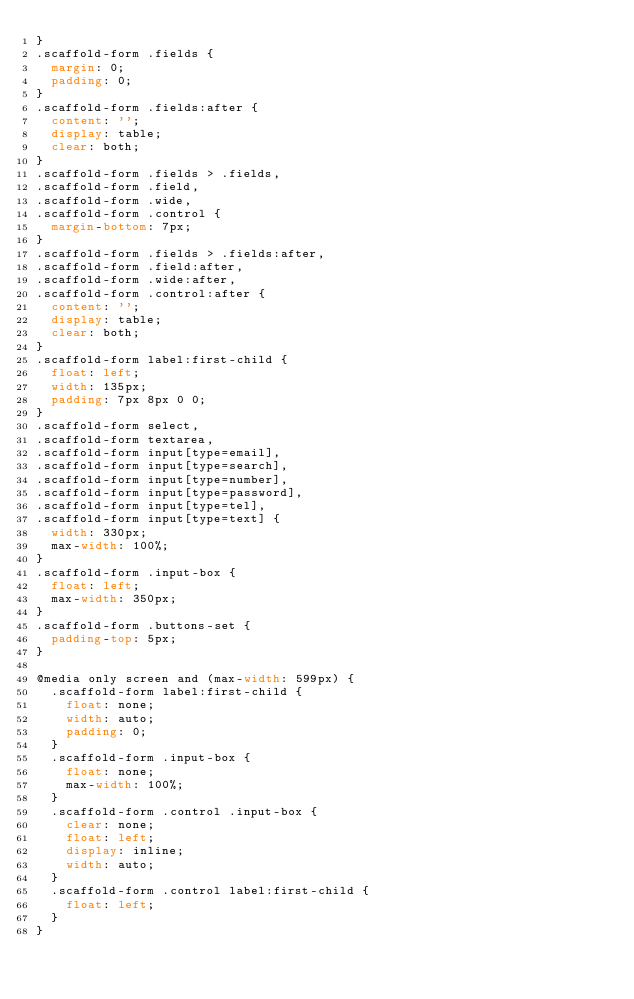Convert code to text. <code><loc_0><loc_0><loc_500><loc_500><_CSS_>}
.scaffold-form .fields {
  margin: 0;
  padding: 0;
}
.scaffold-form .fields:after {
  content: '';
  display: table;
  clear: both;
}
.scaffold-form .fields > .fields,
.scaffold-form .field,
.scaffold-form .wide,
.scaffold-form .control {
  margin-bottom: 7px;
}
.scaffold-form .fields > .fields:after,
.scaffold-form .field:after,
.scaffold-form .wide:after,
.scaffold-form .control:after {
  content: '';
  display: table;
  clear: both;
}
.scaffold-form label:first-child {
  float: left;
  width: 135px;
  padding: 7px 8px 0 0;
}
.scaffold-form select,
.scaffold-form textarea,
.scaffold-form input[type=email],
.scaffold-form input[type=search],
.scaffold-form input[type=number],
.scaffold-form input[type=password],
.scaffold-form input[type=tel],
.scaffold-form input[type=text] {
  width: 330px;
  max-width: 100%;
}
.scaffold-form .input-box {
  float: left;
  max-width: 350px;
}
.scaffold-form .buttons-set {
  padding-top: 5px;
}

@media only screen and (max-width: 599px) {
  .scaffold-form label:first-child {
    float: none;
    width: auto;
    padding: 0;
  }
  .scaffold-form .input-box {
    float: none;
    max-width: 100%;
  }
  .scaffold-form .control .input-box {
    clear: none;
    float: left;
    display: inline;
    width: auto;
  }
  .scaffold-form .control label:first-child {
    float: left;
  }
}
</code> 